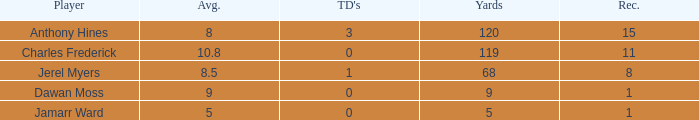What is the average number of TDs when the yards are less than 119, the AVG is larger than 5, and Jamarr Ward is a player? None. 